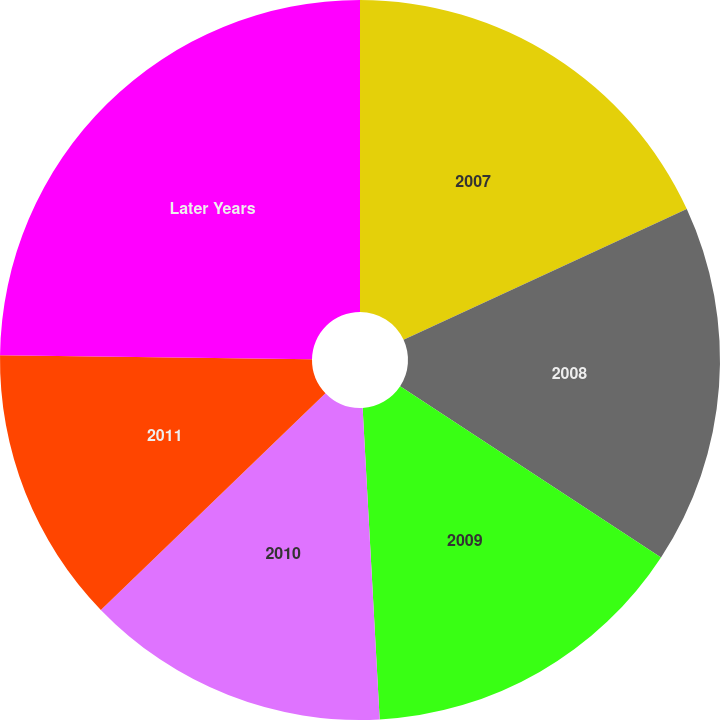Convert chart to OTSL. <chart><loc_0><loc_0><loc_500><loc_500><pie_chart><fcel>2007<fcel>2008<fcel>2009<fcel>2010<fcel>2011<fcel>Later Years<nl><fcel>18.11%<fcel>16.13%<fcel>14.89%<fcel>13.66%<fcel>12.42%<fcel>24.79%<nl></chart> 